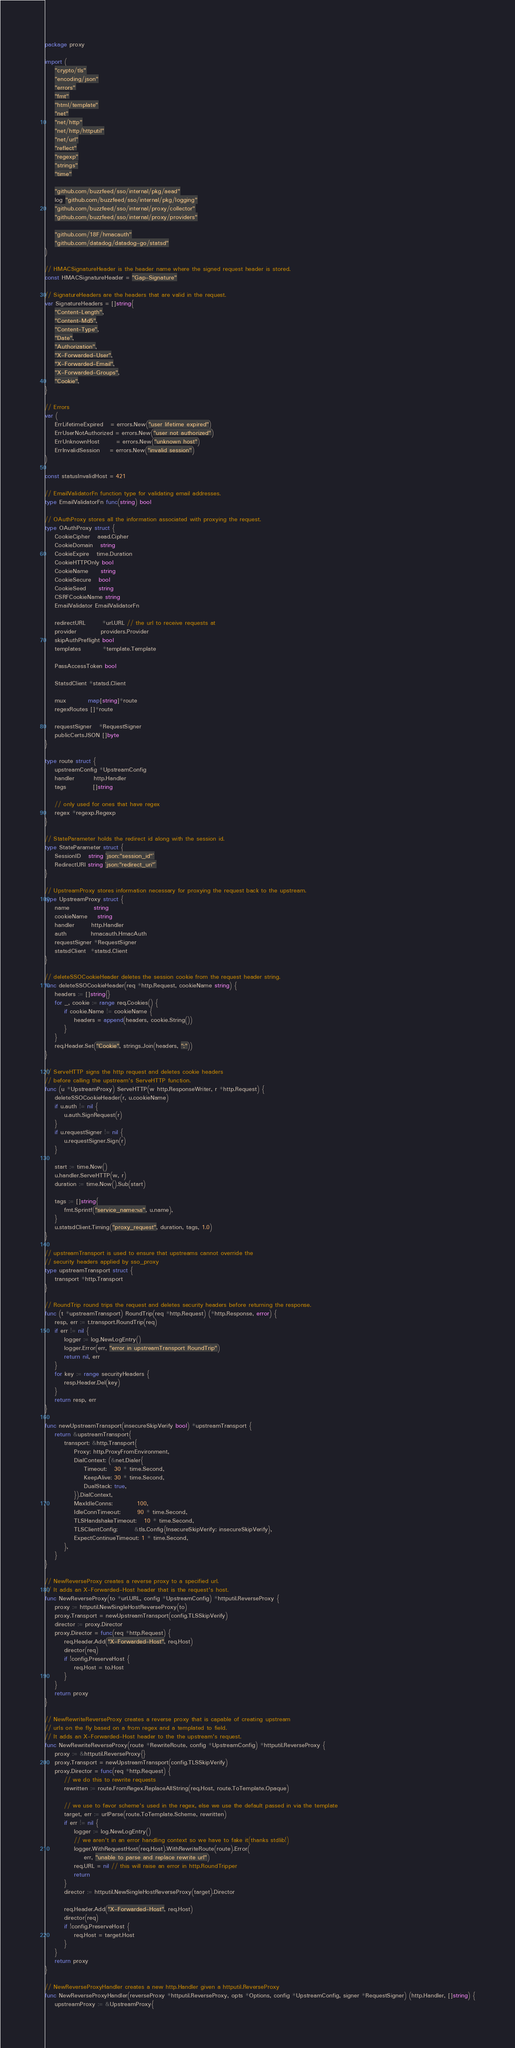Convert code to text. <code><loc_0><loc_0><loc_500><loc_500><_Go_>package proxy

import (
	"crypto/tls"
	"encoding/json"
	"errors"
	"fmt"
	"html/template"
	"net"
	"net/http"
	"net/http/httputil"
	"net/url"
	"reflect"
	"regexp"
	"strings"
	"time"

	"github.com/buzzfeed/sso/internal/pkg/aead"
	log "github.com/buzzfeed/sso/internal/pkg/logging"
	"github.com/buzzfeed/sso/internal/proxy/collector"
	"github.com/buzzfeed/sso/internal/proxy/providers"

	"github.com/18F/hmacauth"
	"github.com/datadog/datadog-go/statsd"
)

// HMACSignatureHeader is the header name where the signed request header is stored.
const HMACSignatureHeader = "Gap-Signature"

// SignatureHeaders are the headers that are valid in the request.
var SignatureHeaders = []string{
	"Content-Length",
	"Content-Md5",
	"Content-Type",
	"Date",
	"Authorization",
	"X-Forwarded-User",
	"X-Forwarded-Email",
	"X-Forwarded-Groups",
	"Cookie",
}

// Errors
var (
	ErrLifetimeExpired   = errors.New("user lifetime expired")
	ErrUserNotAuthorized = errors.New("user not authorized")
	ErrUnknownHost       = errors.New("unknown host")
	ErrInvalidSession    = errors.New("invalid session")
)

const statusInvalidHost = 421

// EmailValidatorFn function type for validating email addresses.
type EmailValidatorFn func(string) bool

// OAuthProxy stores all the information associated with proxying the request.
type OAuthProxy struct {
	CookieCipher   aead.Cipher
	CookieDomain   string
	CookieExpire   time.Duration
	CookieHTTPOnly bool
	CookieName     string
	CookieSecure   bool
	CookieSeed     string
	CSRFCookieName string
	EmailValidator EmailValidatorFn

	redirectURL       *url.URL // the url to receive requests at
	provider          providers.Provider
	skipAuthPreflight bool
	templates         *template.Template

	PassAccessToken bool

	StatsdClient *statsd.Client

	mux         map[string]*route
	regexRoutes []*route

	requestSigner   *RequestSigner
	publicCertsJSON []byte
}

type route struct {
	upstreamConfig *UpstreamConfig
	handler        http.Handler
	tags           []string

	// only used for ones that have regex
	regex *regexp.Regexp
}

// StateParameter holds the redirect id along with the session id.
type StateParameter struct {
	SessionID   string `json:"session_id"`
	RedirectURI string `json:"redirect_uri"`
}

// UpstreamProxy stores information necessary for proxying the request back to the upstream.
type UpstreamProxy struct {
	name          string
	cookieName    string
	handler       http.Handler
	auth          hmacauth.HmacAuth
	requestSigner *RequestSigner
	statsdClient  *statsd.Client
}

// deleteSSOCookieHeader deletes the session cookie from the request header string.
func deleteSSOCookieHeader(req *http.Request, cookieName string) {
	headers := []string{}
	for _, cookie := range req.Cookies() {
		if cookie.Name != cookieName {
			headers = append(headers, cookie.String())
		}
	}
	req.Header.Set("Cookie", strings.Join(headers, ";"))
}

// ServeHTTP signs the http request and deletes cookie headers
// before calling the upstream's ServeHTTP function.
func (u *UpstreamProxy) ServeHTTP(w http.ResponseWriter, r *http.Request) {
	deleteSSOCookieHeader(r, u.cookieName)
	if u.auth != nil {
		u.auth.SignRequest(r)
	}
	if u.requestSigner != nil {
		u.requestSigner.Sign(r)
	}

	start := time.Now()
	u.handler.ServeHTTP(w, r)
	duration := time.Now().Sub(start)

	tags := []string{
		fmt.Sprintf("service_name:%s", u.name),
	}
	u.statsdClient.Timing("proxy_request", duration, tags, 1.0)
}

// upstreamTransport is used to ensure that upstreams cannot override the
// security headers applied by sso_proxy
type upstreamTransport struct {
	transport *http.Transport
}

// RoundTrip round trips the request and deletes security headers before returning the response.
func (t *upstreamTransport) RoundTrip(req *http.Request) (*http.Response, error) {
	resp, err := t.transport.RoundTrip(req)
	if err != nil {
		logger := log.NewLogEntry()
		logger.Error(err, "error in upstreamTransport RoundTrip")
		return nil, err
	}
	for key := range securityHeaders {
		resp.Header.Del(key)
	}
	return resp, err
}

func newUpstreamTransport(insecureSkipVerify bool) *upstreamTransport {
	return &upstreamTransport{
		transport: &http.Transport{
			Proxy: http.ProxyFromEnvironment,
			DialContext: (&net.Dialer{
				Timeout:   30 * time.Second,
				KeepAlive: 30 * time.Second,
				DualStack: true,
			}).DialContext,
			MaxIdleConns:          100,
			IdleConnTimeout:       90 * time.Second,
			TLSHandshakeTimeout:   10 * time.Second,
			TLSClientConfig:       &tls.Config{InsecureSkipVerify: insecureSkipVerify},
			ExpectContinueTimeout: 1 * time.Second,
		},
	}
}

// NewReverseProxy creates a reverse proxy to a specified url.
// It adds an X-Forwarded-Host header that is the request's host.
func NewReverseProxy(to *url.URL, config *UpstreamConfig) *httputil.ReverseProxy {
	proxy := httputil.NewSingleHostReverseProxy(to)
	proxy.Transport = newUpstreamTransport(config.TLSSkipVerify)
	director := proxy.Director
	proxy.Director = func(req *http.Request) {
		req.Header.Add("X-Forwarded-Host", req.Host)
		director(req)
		if !config.PreserveHost {
			req.Host = to.Host
		}
	}
	return proxy
}

// NewRewriteReverseProxy creates a reverse proxy that is capable of creating upstream
// urls on the fly based on a from regex and a templated to field.
// It adds an X-Forwarded-Host header to the the upstream's request.
func NewRewriteReverseProxy(route *RewriteRoute, config *UpstreamConfig) *httputil.ReverseProxy {
	proxy := &httputil.ReverseProxy{}
	proxy.Transport = newUpstreamTransport(config.TLSSkipVerify)
	proxy.Director = func(req *http.Request) {
		// we do this to rewrite requests
		rewritten := route.FromRegex.ReplaceAllString(req.Host, route.ToTemplate.Opaque)

		// we use to favor scheme's used in the regex, else we use the default passed in via the template
		target, err := urlParse(route.ToTemplate.Scheme, rewritten)
		if err != nil {
			logger := log.NewLogEntry()
			// we aren't in an error handling context so we have to fake it(thanks stdlib!)
			logger.WithRequestHost(req.Host).WithRewriteRoute(route).Error(
				err, "unable to parse and replace rewrite url")
			req.URL = nil // this will raise an error in http.RoundTripper
			return
		}
		director := httputil.NewSingleHostReverseProxy(target).Director

		req.Header.Add("X-Forwarded-Host", req.Host)
		director(req)
		if !config.PreserveHost {
			req.Host = target.Host
		}
	}
	return proxy
}

// NewReverseProxyHandler creates a new http.Handler given a httputil.ReverseProxy
func NewReverseProxyHandler(reverseProxy *httputil.ReverseProxy, opts *Options, config *UpstreamConfig, signer *RequestSigner) (http.Handler, []string) {
	upstreamProxy := &UpstreamProxy{</code> 